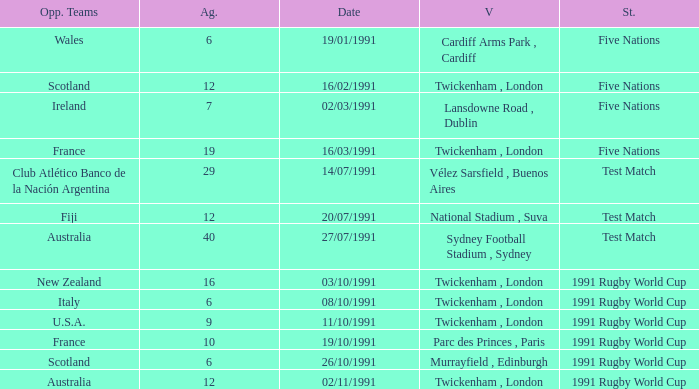What is Opposing Teams, when Date is "11/10/1991"? U.S.A. 